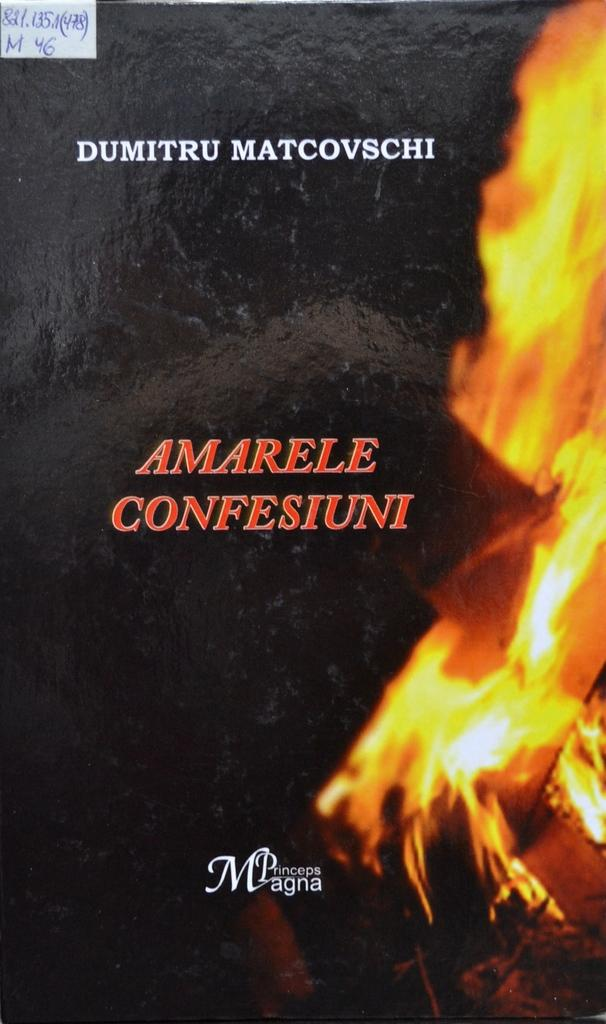<image>
Share a concise interpretation of the image provided. A black package with a flame that says Amarele Confesiuni 